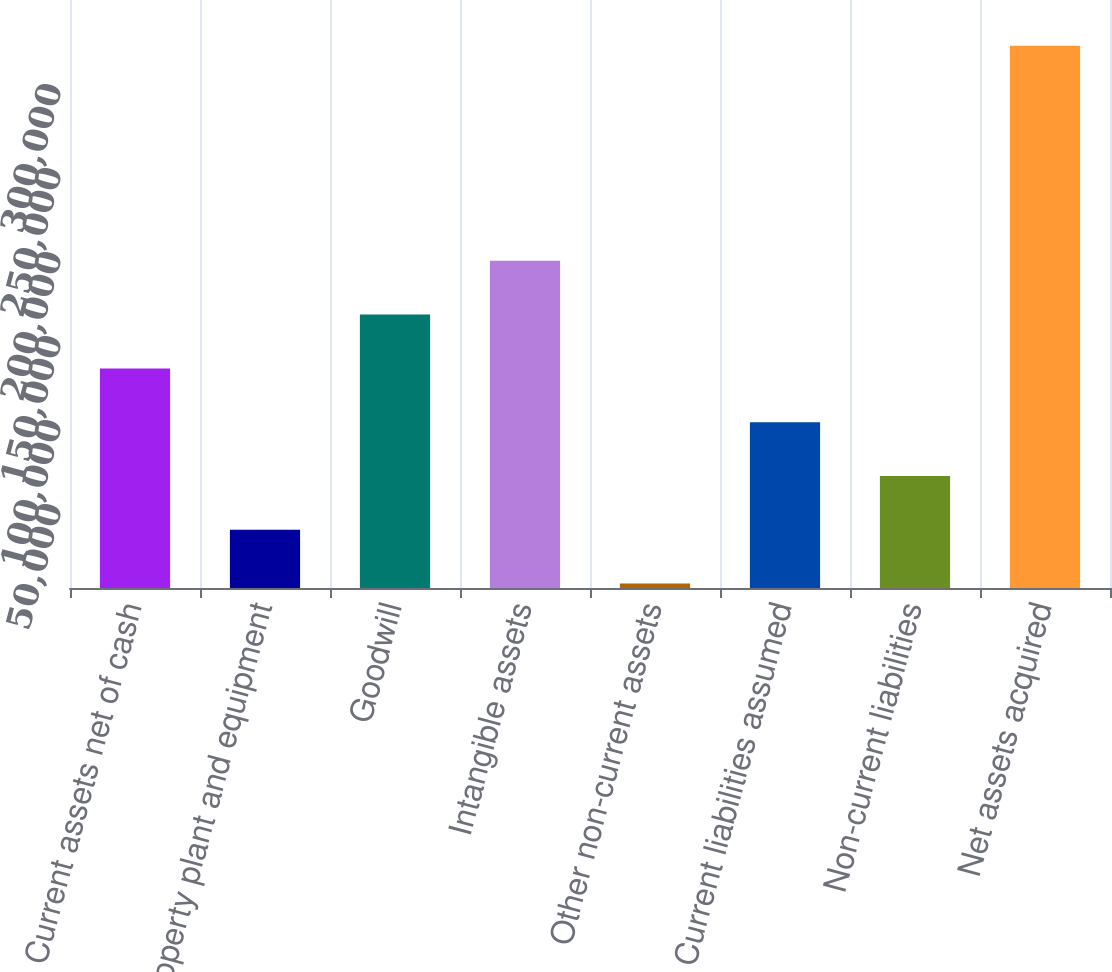<chart> <loc_0><loc_0><loc_500><loc_500><bar_chart><fcel>Current assets net of cash<fcel>Property plant and equipment<fcel>Goodwill<fcel>Intangible assets<fcel>Other non-current assets<fcel>Current liabilities assumed<fcel>Non-current liabilities<fcel>Net assets acquired<nl><fcel>130708<fcel>34643.6<fcel>162730<fcel>194752<fcel>2622<fcel>98686.8<fcel>66665.2<fcel>322838<nl></chart> 